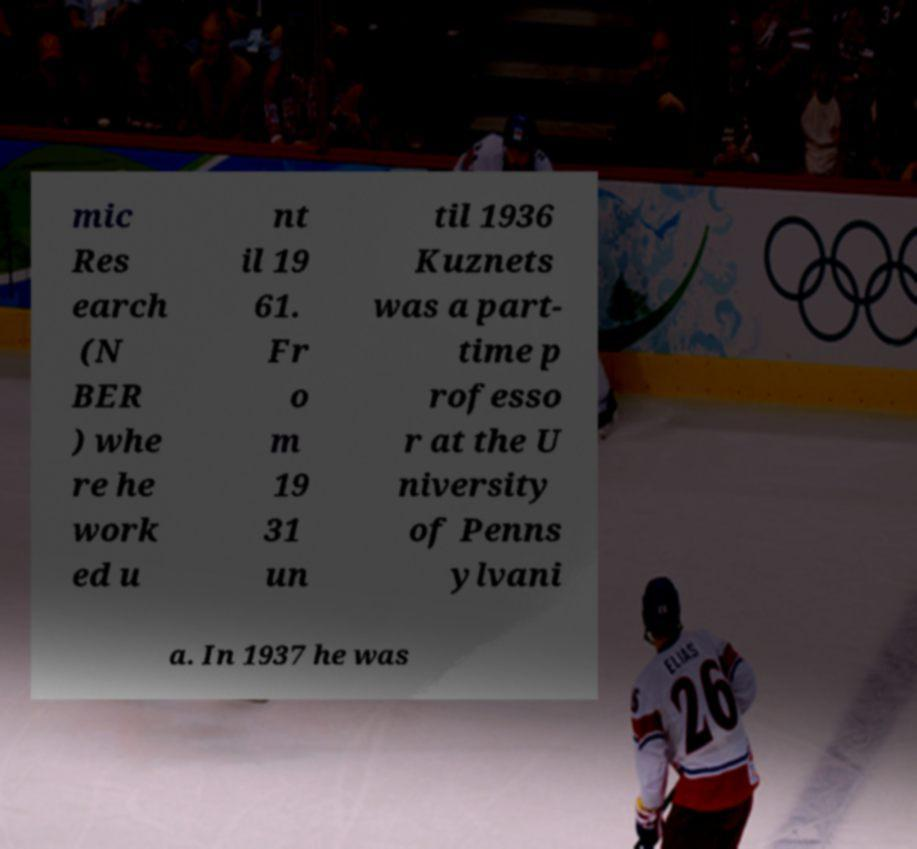I need the written content from this picture converted into text. Can you do that? mic Res earch (N BER ) whe re he work ed u nt il 19 61. Fr o m 19 31 un til 1936 Kuznets was a part- time p rofesso r at the U niversity of Penns ylvani a. In 1937 he was 